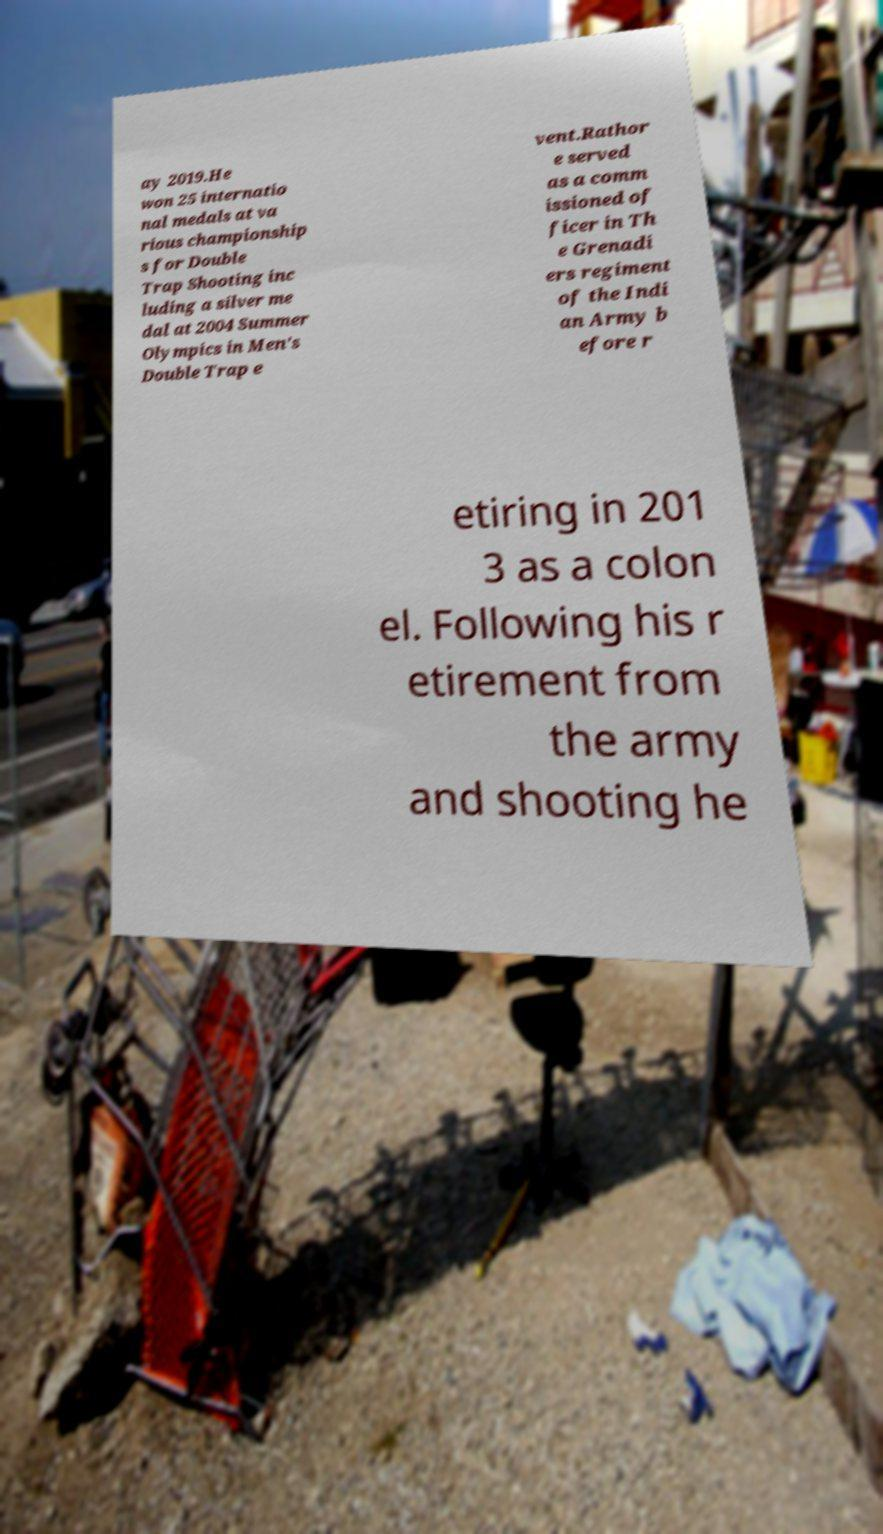Could you extract and type out the text from this image? ay 2019.He won 25 internatio nal medals at va rious championship s for Double Trap Shooting inc luding a silver me dal at 2004 Summer Olympics in Men's Double Trap e vent.Rathor e served as a comm issioned of ficer in Th e Grenadi ers regiment of the Indi an Army b efore r etiring in 201 3 as a colon el. Following his r etirement from the army and shooting he 